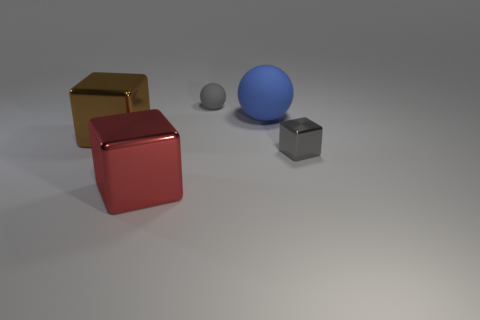Subtract all tiny gray metallic cubes. How many cubes are left? 2 Add 4 cyan metal spheres. How many objects exist? 9 Subtract all cubes. How many objects are left? 2 Subtract all purple cubes. Subtract all yellow cylinders. How many cubes are left? 3 Subtract all big spheres. Subtract all big red cubes. How many objects are left? 3 Add 3 metallic things. How many metallic things are left? 6 Add 1 brown matte blocks. How many brown matte blocks exist? 1 Subtract 1 gray cubes. How many objects are left? 4 